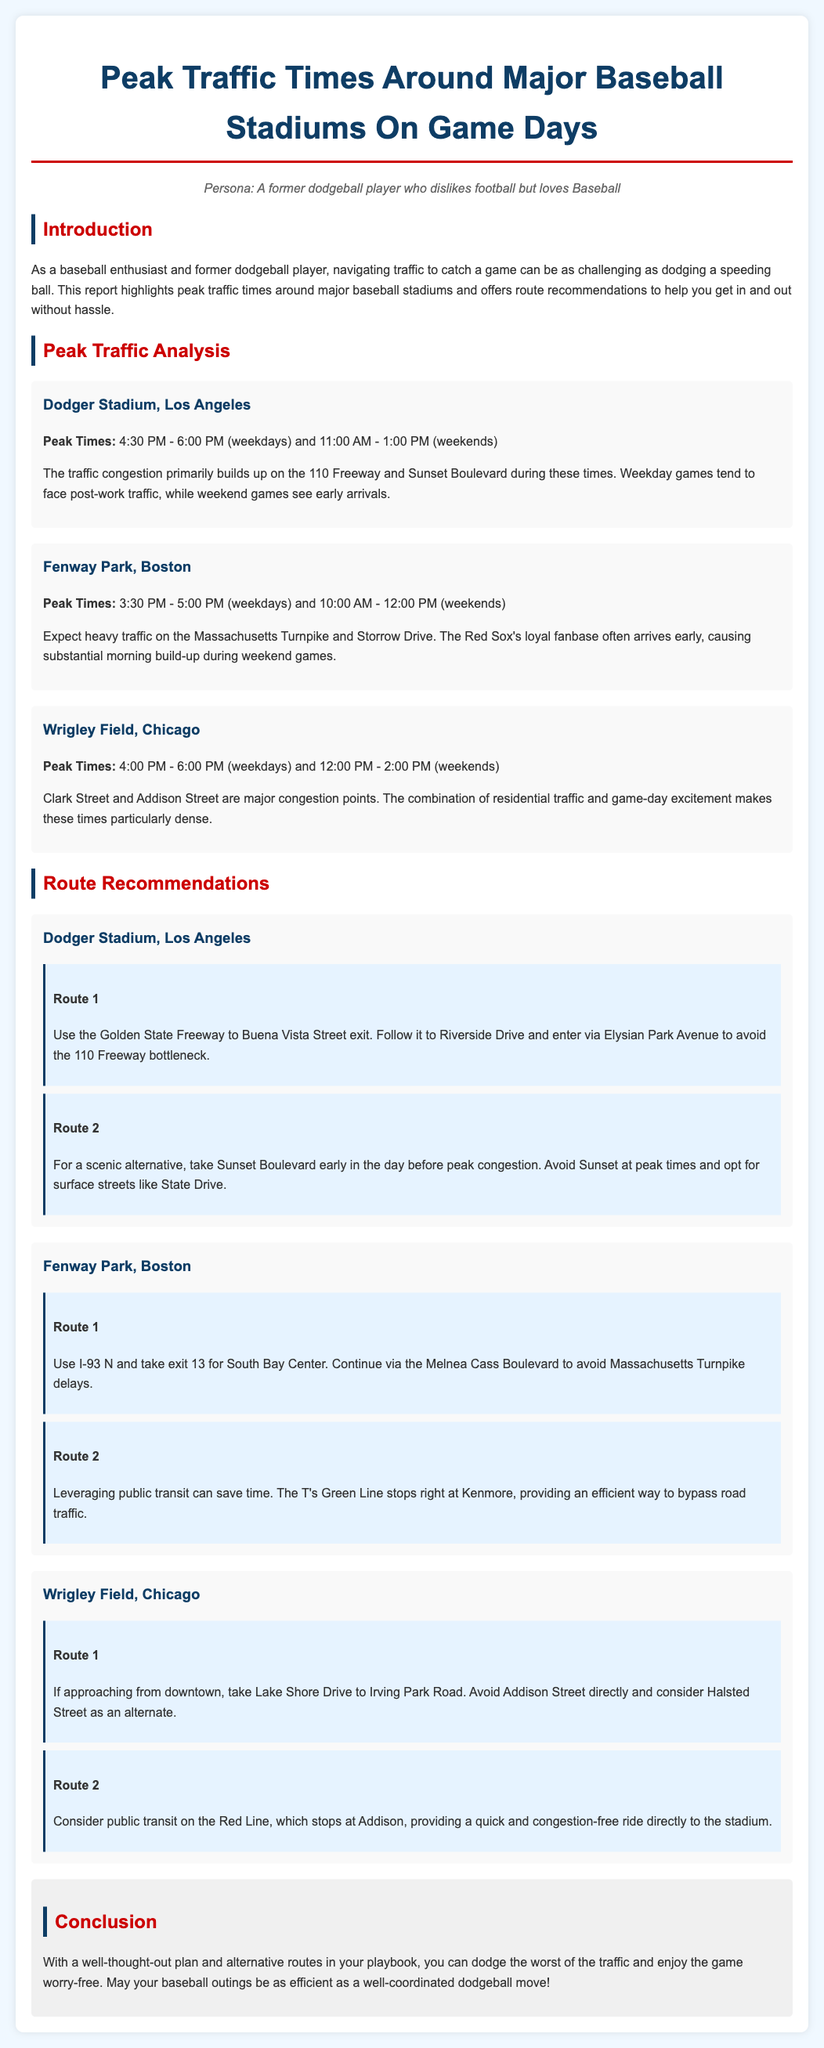What are the peak times for Dodger Stadium on weekdays? The peak times for Dodger Stadium on weekdays are mentioned as 4:30 PM - 6:00 PM.
Answer: 4:30 PM - 6:00 PM What primary route is recommended to reach Dodger Stadium? Route 1 for Dodger Stadium suggests using the Golden State Freeway to Buena Vista Street exit and following it to Riverside Drive.
Answer: Golden State Freeway to Buena Vista Street exit What is the peak traffic time for Wrigley Field on weekends? The peak time for Wrigley Field on weekends is stated as 12:00 PM - 2:00 PM.
Answer: 12:00 PM - 2:00 PM What major road should be avoided when approaching Fenway Park on game days? The document indicates that the Massachusetts Turnpike experiences heavy traffic that should be avoided.
Answer: Massachusetts Turnpike Which public transit option is mentioned for accessing Wrigley Field? The Red Line public transit option is referred to for a quick ride to Wrigley Field.
Answer: Red Line What is the conclusion's message regarding game attendance? The conclusion emphasizes planning and alternative routes to dodge traffic and enjoy the game.
Answer: Plan and use alternative routes 